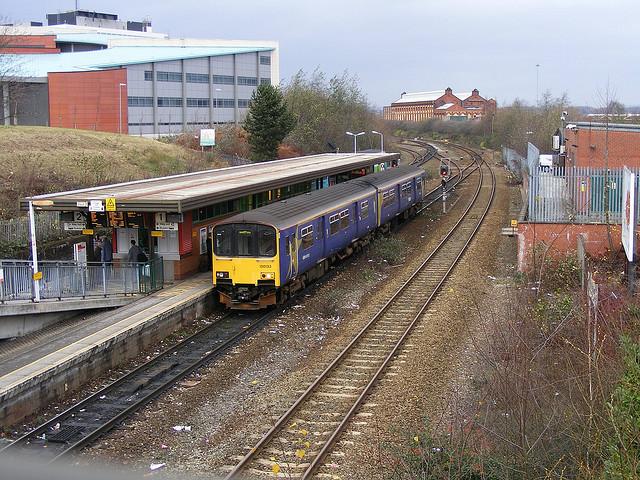Is the train in motion?
Give a very brief answer. No. What color is the train?
Short answer required. Blue. Is the train at a train station?
Concise answer only. Yes. Is this a freight train?
Write a very short answer. No. 